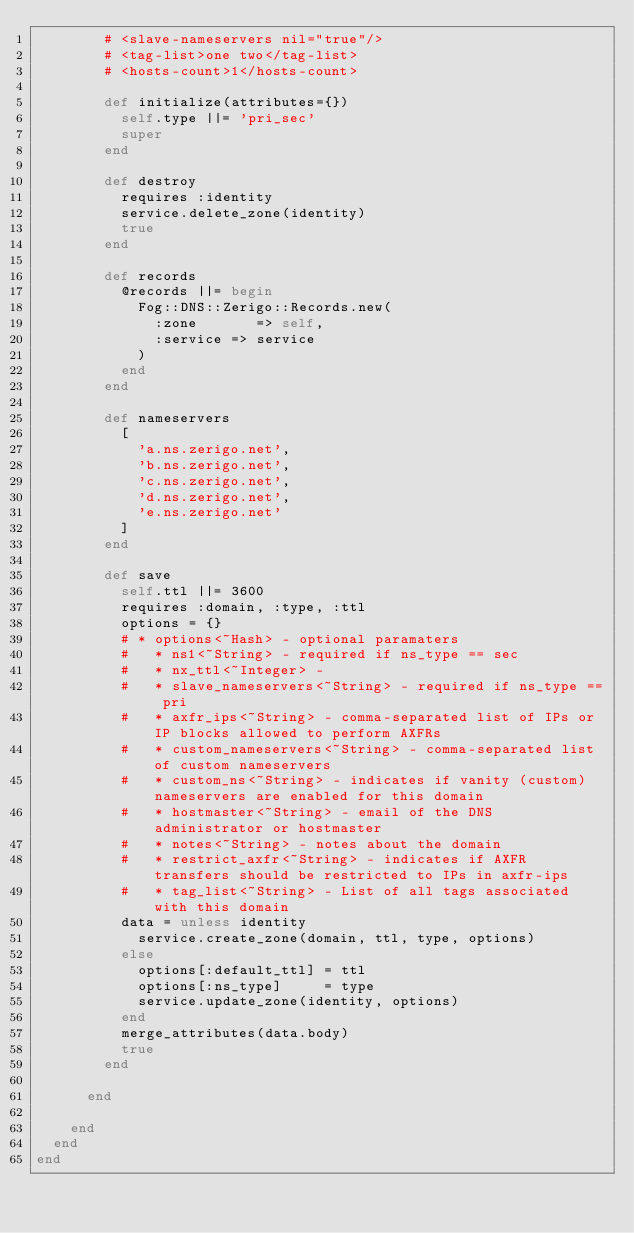<code> <loc_0><loc_0><loc_500><loc_500><_Ruby_>        # <slave-nameservers nil="true"/>
        # <tag-list>one two</tag-list>
        # <hosts-count>1</hosts-count>

        def initialize(attributes={})
          self.type ||= 'pri_sec'
          super
        end

        def destroy
          requires :identity
          service.delete_zone(identity)
          true
        end

        def records
          @records ||= begin
            Fog::DNS::Zerigo::Records.new(
              :zone       => self,
              :service => service
            )
          end
        end

        def nameservers
          [
            'a.ns.zerigo.net',
            'b.ns.zerigo.net',
            'c.ns.zerigo.net',
            'd.ns.zerigo.net',
            'e.ns.zerigo.net'
          ]
        end

        def save
          self.ttl ||= 3600
          requires :domain, :type, :ttl
          options = {}
          # * options<~Hash> - optional paramaters
          #   * ns1<~String> - required if ns_type == sec
          #   * nx_ttl<~Integer> -
          #   * slave_nameservers<~String> - required if ns_type == pri
          #   * axfr_ips<~String> - comma-separated list of IPs or IP blocks allowed to perform AXFRs
          #   * custom_nameservers<~String> - comma-separated list of custom nameservers
          #   * custom_ns<~String> - indicates if vanity (custom) nameservers are enabled for this domain
          #   * hostmaster<~String> - email of the DNS administrator or hostmaster
          #   * notes<~String> - notes about the domain
          #   * restrict_axfr<~String> - indicates if AXFR transfers should be restricted to IPs in axfr-ips
          #   * tag_list<~String> - List of all tags associated with this domain
          data = unless identity
            service.create_zone(domain, ttl, type, options)
          else
            options[:default_ttl] = ttl
            options[:ns_type]     = type
            service.update_zone(identity, options)
          end
          merge_attributes(data.body)
          true
        end

      end

    end
  end
end
</code> 